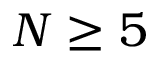<formula> <loc_0><loc_0><loc_500><loc_500>N \geq 5</formula> 